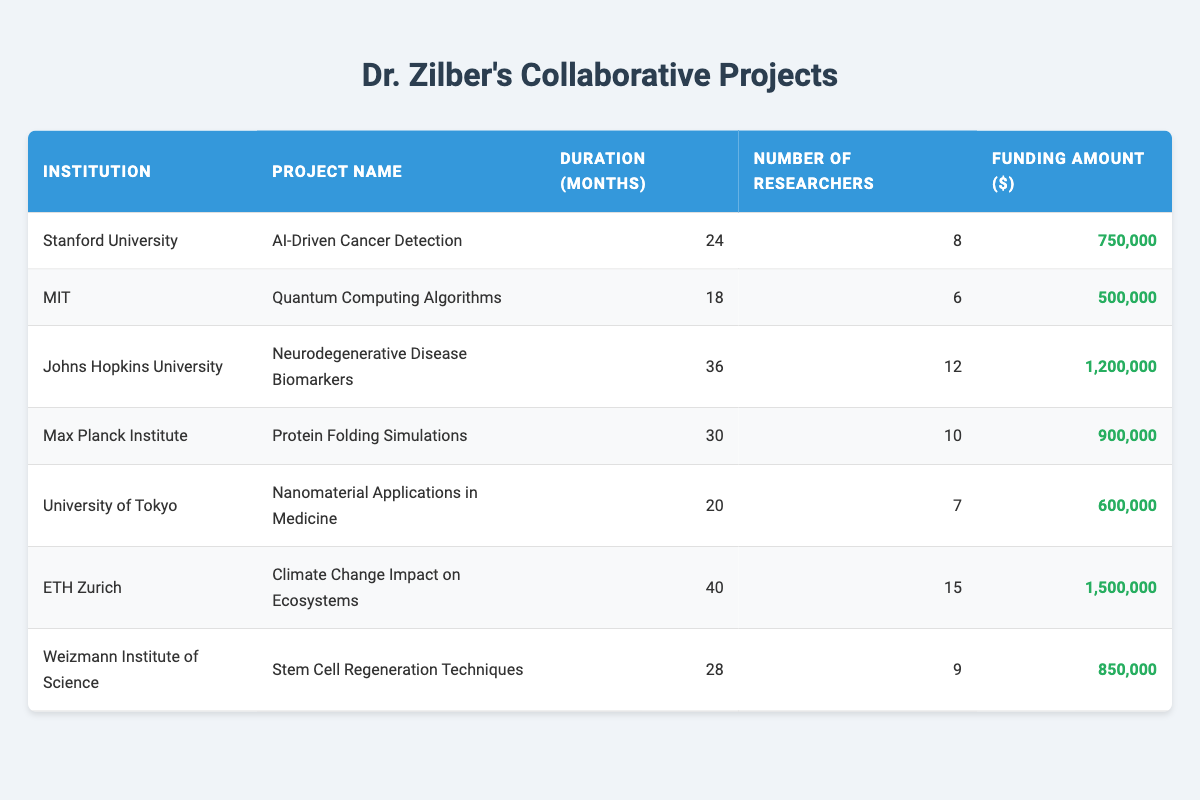What is the funding amount for the project "Neurodegenerative Disease Biomarkers"? The table lists the project "Neurodegenerative Disease Biomarkers" under Johns Hopkins University, and the funding amount is specified in the last column as $1,200,000.
Answer: 1,200,000 Which project lasted the longest? The table shows the duration of projects under the column "Duration (months)." The project with the longest duration is "Climate Change Impact on Ecosystems" at ETH Zurich, lasting 40 months.
Answer: Climate Change Impact on Ecosystems How many researchers were involved in the project with the highest funding? To determine the project with the highest funding, we review the "Funding Amount ($)" column. The highest funding is for the ETH Zurich project at $1,500,000, which involves 15 researchers.
Answer: 15 What is the average duration of the projects listed in the table? We calculate the average duration by summing the months: (24 + 18 + 36 + 30 + 20 + 40 + 28) = 196. Then, we divide by the number of projects, which is 7: 196/7 = 28. Therefore, the average duration is 28 months.
Answer: 28 Is the project "Quantum Computing Algorithms" funded more than $600,000? The funding amount for "Quantum Computing Algorithms" under MIT is $500,000, which is less than $600,000. Thus, the answer is no.
Answer: No Which institution has the highest total funding across its projects? Reviewing the funding amounts: Stanford University has $750,000, MIT has $500,000, Johns Hopkins University has $1,200,000, Max Planck Institute has $900,000, University of Tokyo has $600,000, ETH Zurich has $1,500,000, and Weizmann Institute of Science has $850,000. The highest total is $1,500,000 from ETH Zurich.
Answer: ETH Zurich What is the total funding for all projects involving Dr. Zilber? By summing all the funding amounts: $750,000 + $500,000 + $1,200,000 + $900,000 + $600,000 + $1,500,000 + $850,000 = $5,300,000, we find the total funding for Dr. Zilber's projects.
Answer: 5,300,000 Did Johns Hopkins University collaborate on more than one project listed in the table? The table lists only one project for Johns Hopkins University, which is "Neurodegenerative Disease Biomarkers." Therefore, the answer is no.
Answer: No 